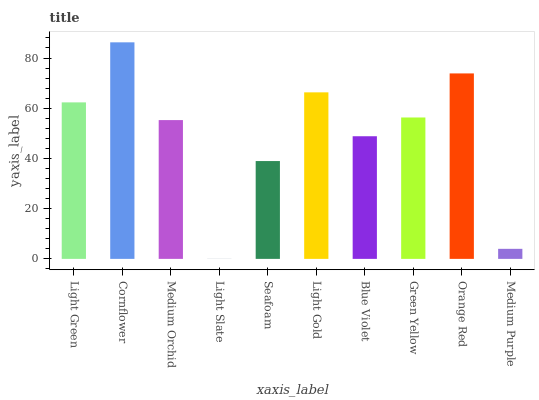Is Light Slate the minimum?
Answer yes or no. Yes. Is Cornflower the maximum?
Answer yes or no. Yes. Is Medium Orchid the minimum?
Answer yes or no. No. Is Medium Orchid the maximum?
Answer yes or no. No. Is Cornflower greater than Medium Orchid?
Answer yes or no. Yes. Is Medium Orchid less than Cornflower?
Answer yes or no. Yes. Is Medium Orchid greater than Cornflower?
Answer yes or no. No. Is Cornflower less than Medium Orchid?
Answer yes or no. No. Is Green Yellow the high median?
Answer yes or no. Yes. Is Medium Orchid the low median?
Answer yes or no. Yes. Is Light Gold the high median?
Answer yes or no. No. Is Medium Purple the low median?
Answer yes or no. No. 